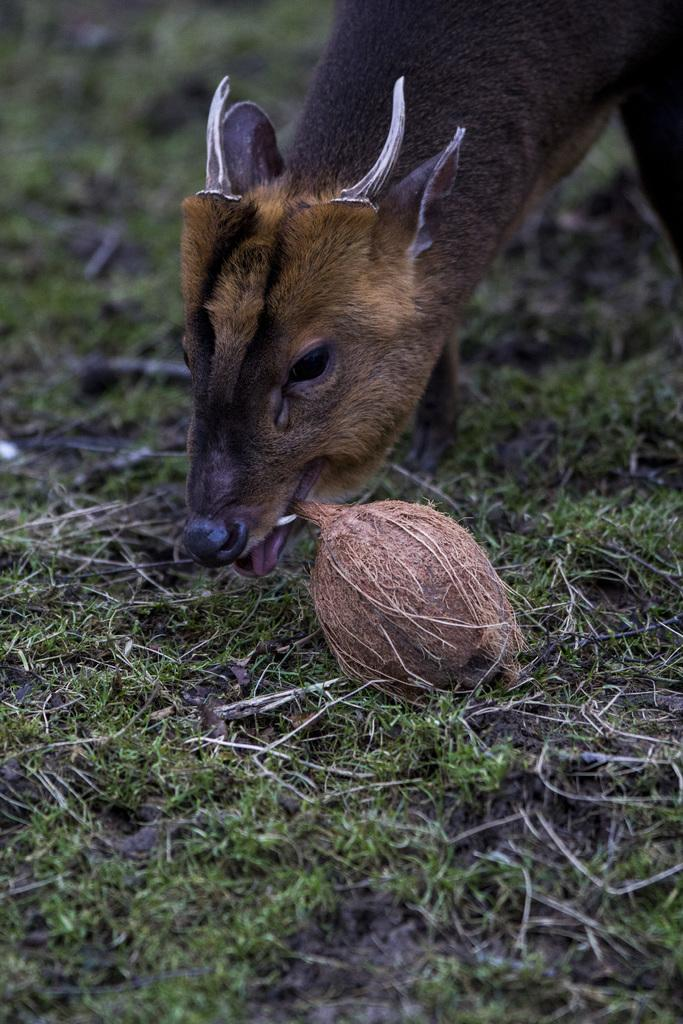What type of animal can be seen in the image? There is an animal in the image. What is the animal doing in the image? The animal is eating a coconut. What type of vegetation is visible on the ground in the image? There is grass visible on the ground in the image. How many eggs are visible in the image? There are no eggs present in the image. What type of magic is the animal using to eat the coconut in the image? There is no magic present in the image; the animal is simply eating the coconut. 